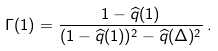Convert formula to latex. <formula><loc_0><loc_0><loc_500><loc_500>\Gamma ( 1 ) = \frac { 1 - \widehat { q } ( 1 ) } { ( 1 - \widehat { q } ( 1 ) ) ^ { 2 } - \widehat { q } ( \Delta ) ^ { 2 } } \, .</formula> 